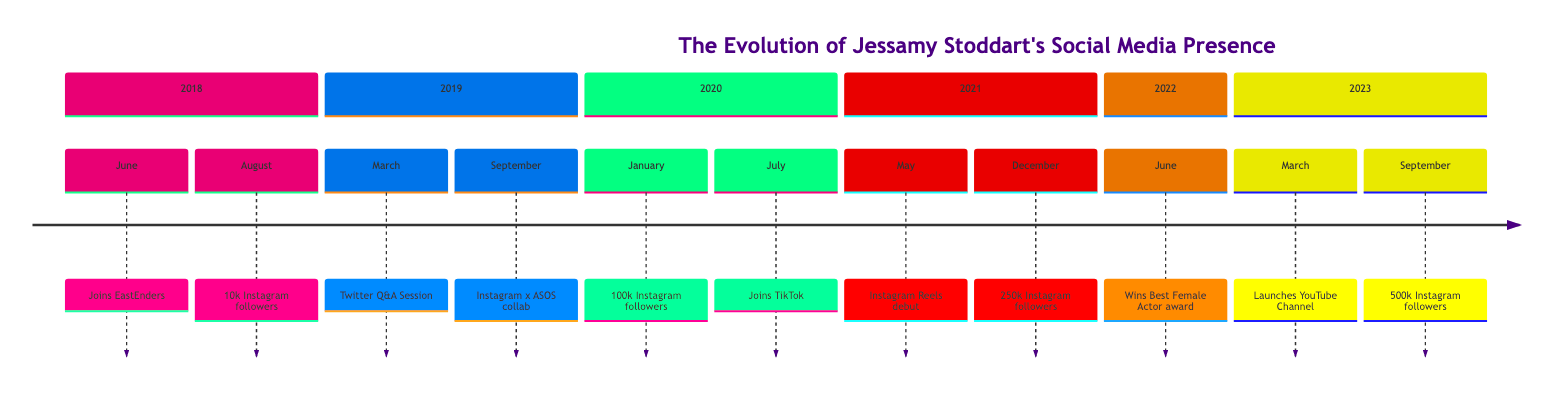What event took place on June 1, 2018? The diagram indicates that on June 1, 2018, Jessamy Stoddart joined EastEnders, marking the start of her role in the popular BBC soap opera.
Answer: Joins EastEnders How many followers did Jessamy have on Instagram by August 15, 2018? The timeline specifies that on August 15, 2018, Jessamy Stoddart reached her first 10,000 followers on Instagram, indicating her early social media growth post-EastEnders.
Answer: 10,000 What milestone in follower count did Jessamy reach on January 30, 2020? According to the timeline, her follower count on Instagram reached 100,000 by January 30, 2020, showcasing significant growth in her social media presence.
Answer: 100,000 Which event occurred directly after the Instagram collaboration with ASOS? The timeline shows that after the Instagram collaboration with ASOS on September 12, 2019, Jessamy hosted a Twitter Q&A session on March 20, 2019. Thus, the Q&A session came after the ASOS collaboration in the chronology of events.
Answer: Twitter Q&A Session In what month and year did Jessamy debut on TikTok? The diagram indicates that Jessamy Stoddart joined TikTok in July 2020, marking her expansion into another social media platform.
Answer: July 2020 What was the significance of June 25, 2022, in Jessamy's timeline? On June 25, 2022, Jessamy won the Best Female Actor award, which is a significant milestone celebrated by her fans, resulting in a notable boost in her follower count.
Answer: Won the Best Female Actor award By how much did Jessamy's Instagram followers increase from January 30, 2020, to December 1, 2021? The timeline shows that Jessamy had 100,000 followers on January 30, 2020, and reached 250,000 by December 1, 2021. Therefore, the increase is 250,000 - 100,000 = 150,000 followers.
Answer: 150,000 What social media platform did Jessamy launch on March 18, 2023? The timeline indicates that she launched her official YouTube channel on March 18, 2023, which indicates an expansion of her social media presence.
Answer: YouTube Channel What is the final milestone mentioned in the timeline for Jessamy's Instagram follower count? According to the diagram, the final milestone mentioned for her Instagram follower count is reaching 500,000 on September 5, 2023, which reflects her growing influence over time.
Answer: 500,000 